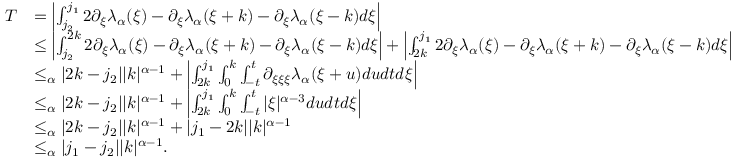<formula> <loc_0><loc_0><loc_500><loc_500>\begin{array} { r l } { T } & { = \left | \int _ { j _ { 2 } } ^ { j _ { 1 } } 2 \partial _ { \xi } \lambda _ { \alpha } ( \xi ) - \partial _ { \xi } \lambda _ { \alpha } ( \xi + k ) - \partial _ { \xi } \lambda _ { \alpha } ( \xi - k ) d \xi \right | } \\ & { \leq \left | \int _ { j _ { 2 } } ^ { 2 k } 2 \partial _ { \xi } \lambda _ { \alpha } ( \xi ) - \partial _ { \xi } \lambda _ { \alpha } ( \xi + k ) - \partial _ { \xi } \lambda _ { \alpha } ( \xi - k ) d \xi \right | + \left | \int _ { 2 k } ^ { j _ { 1 } } 2 \partial _ { \xi } \lambda _ { \alpha } ( \xi ) - \partial _ { \xi } \lambda _ { \alpha } ( \xi + k ) - \partial _ { \xi } \lambda _ { \alpha } ( \xi - k ) d \xi \right | } \\ & { \leq _ { \alpha } | 2 k - j _ { 2 } | | k | ^ { \alpha - 1 } + \left | \int _ { 2 k } ^ { j _ { 1 } } \int _ { 0 } ^ { k } \int _ { - t } ^ { t } \partial _ { \xi \xi \xi } \lambda _ { \alpha } ( \xi + u ) d u d t d \xi \right | } \\ & { \leq _ { \alpha } | 2 k - j _ { 2 } | | k | ^ { \alpha - 1 } + \left | \int _ { 2 k } ^ { j _ { 1 } } \int _ { 0 } ^ { k } \int _ { - t } ^ { t } | \xi | ^ { \alpha - 3 } d u d t d \xi \right | } \\ & { \leq _ { \alpha } | 2 k - j _ { 2 } | | k | ^ { \alpha - 1 } + | j _ { 1 } - 2 k | | k | ^ { \alpha - 1 } } \\ & { \leq _ { \alpha } | j _ { 1 } - j _ { 2 } | | k | ^ { \alpha - 1 } . } \end{array}</formula> 